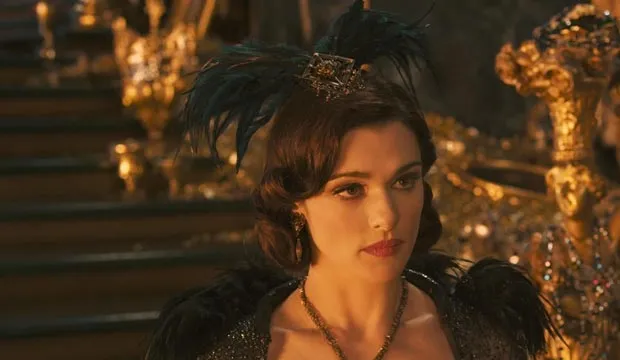Imagine Evanora in an alternate universe where she is not a witch but a queen. How would her life be? In an alternate universe, Evanora is a revered queen known for her wisdom and grace. Her reign brings prosperity and peace to the kingdom. Adorned in royal gowns of silk and jewels, she presides over grand courts and benevolent councils. Her days are filled with diplomatic meetings, cultural celebrations, and efforts to improve her subjects' lives. Despite the power struggles and challenges of ruling, she finds solace in the genuine adoration of her people and the fulfillment of leading with compassion and justice. 